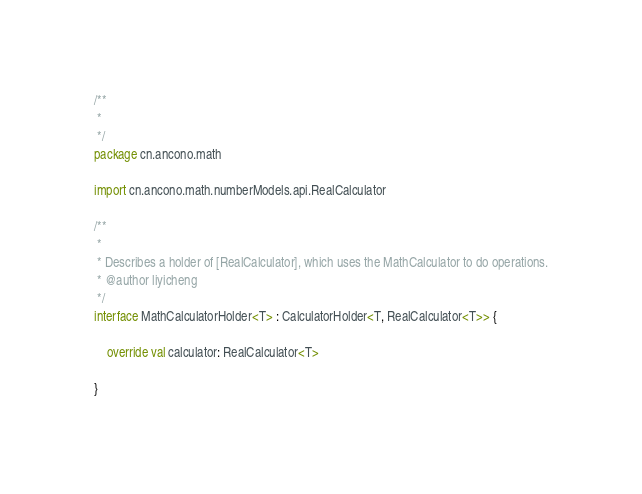<code> <loc_0><loc_0><loc_500><loc_500><_Kotlin_>/**
 *
 */
package cn.ancono.math

import cn.ancono.math.numberModels.api.RealCalculator

/**
 *
 * Describes a holder of [RealCalculator], which uses the MathCalculator to do operations.
 * @author liyicheng
 */
interface MathCalculatorHolder<T> : CalculatorHolder<T, RealCalculator<T>> {

    override val calculator: RealCalculator<T>

}
</code> 